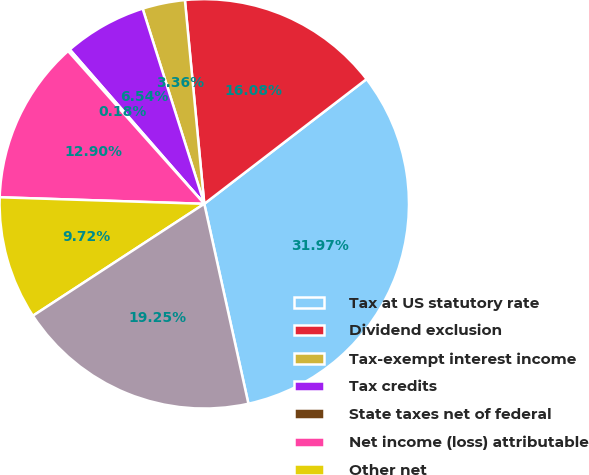Convert chart to OTSL. <chart><loc_0><loc_0><loc_500><loc_500><pie_chart><fcel>Tax at US statutory rate<fcel>Dividend exclusion<fcel>Tax-exempt interest income<fcel>Tax credits<fcel>State taxes net of federal<fcel>Net income (loss) attributable<fcel>Other net<fcel>Income tax provision<nl><fcel>31.97%<fcel>16.08%<fcel>3.36%<fcel>6.54%<fcel>0.18%<fcel>12.9%<fcel>9.72%<fcel>19.25%<nl></chart> 